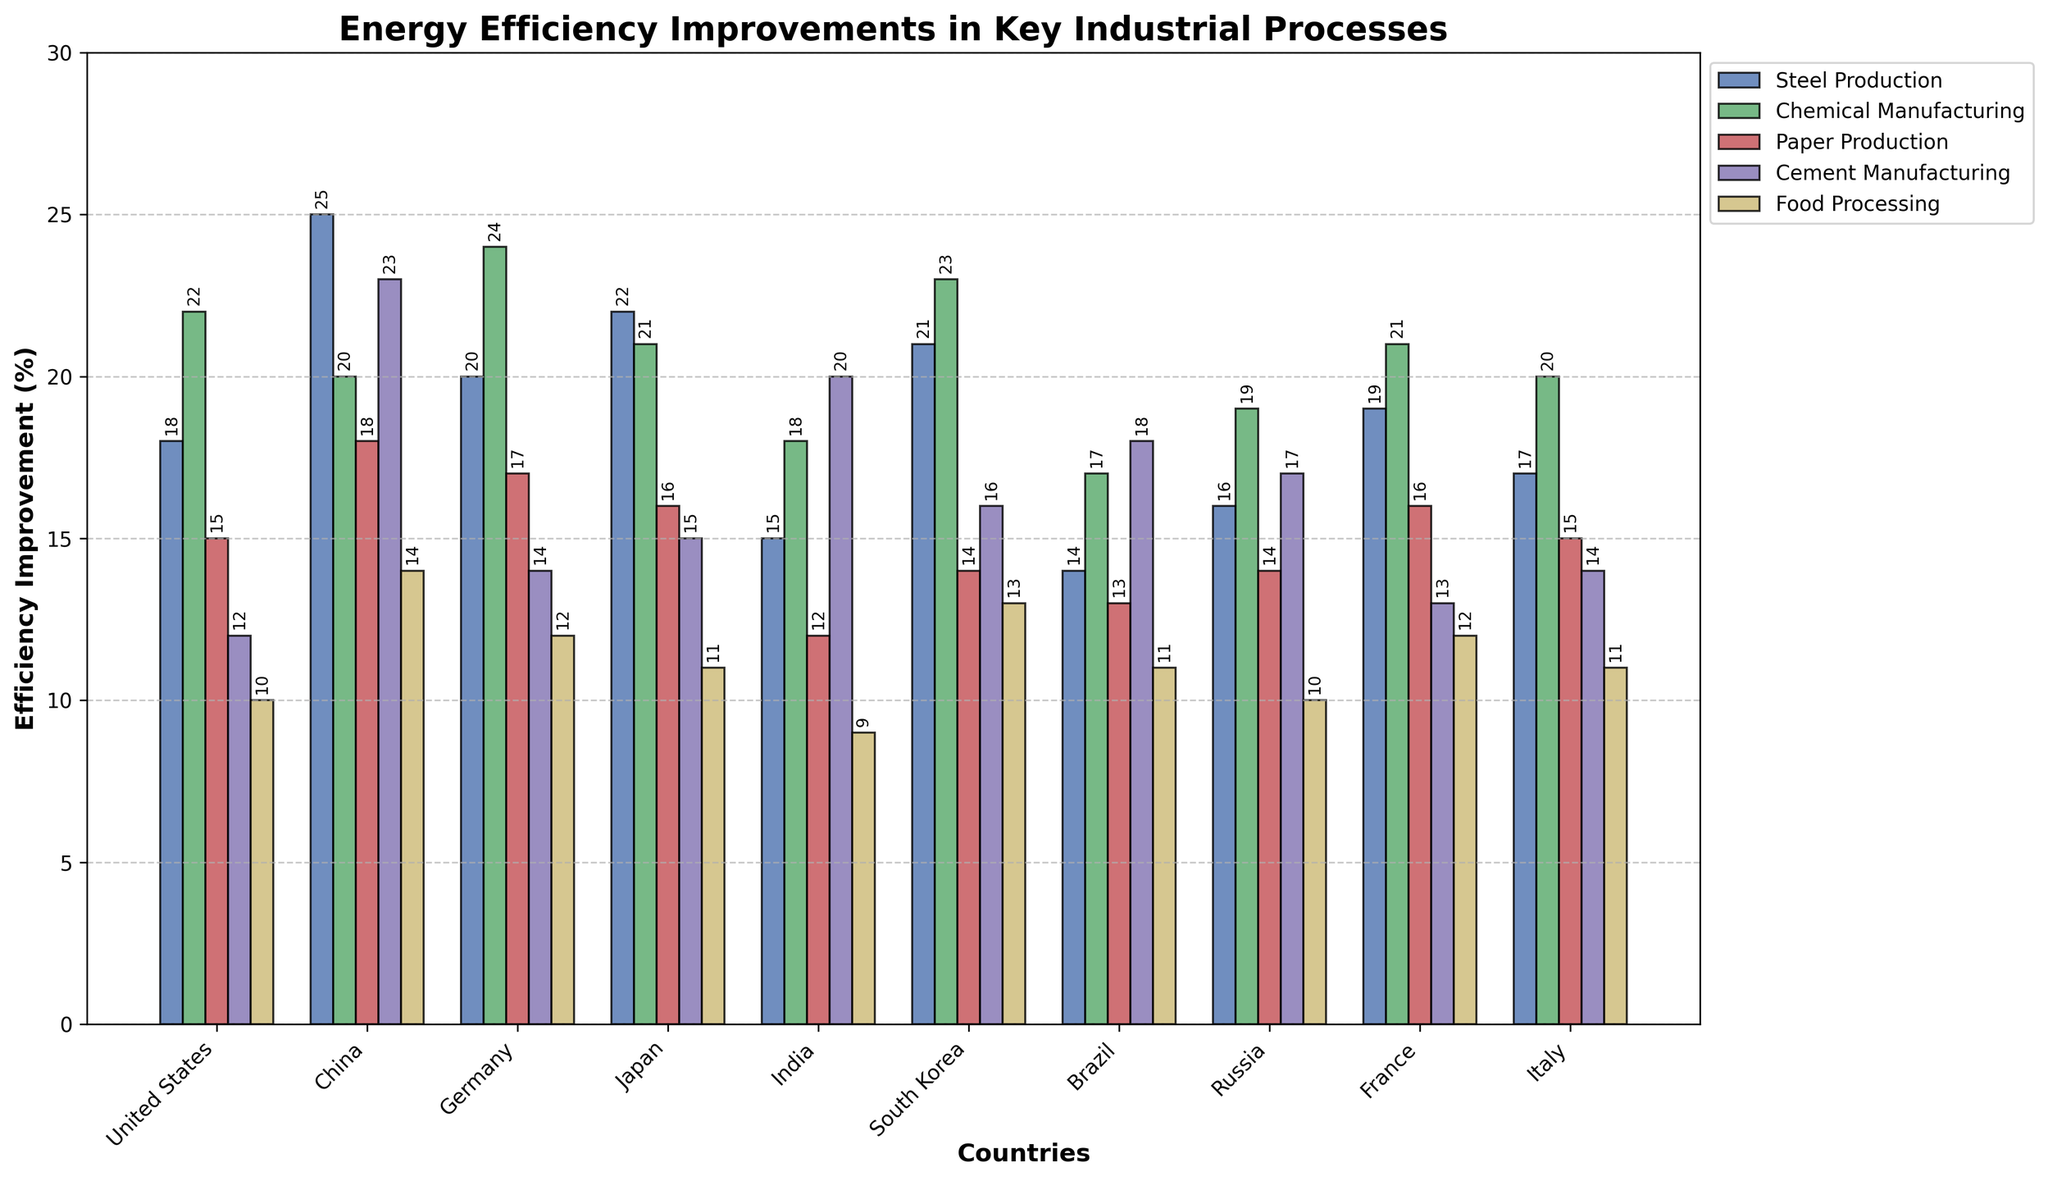What is the average energy efficiency improvement in Steel Production for all countries combined? First, sum the percentages of Steel Production efficiency improvements for each country: 18 (US) + 25 (China) + 20 (Germany) + 22 (Japan) + 15 (India) + 21 (South Korea) + 14 (Brazil) + 16 (Russia) + 19 (France) + 17 (Italy) = 187. Then, divide by the number of countries (10), so 187/10 = 18.7.
Answer: 18.7% Which country has the highest efficiency improvement in Chemical Manufacturing? By examining the heights of the Chemical Manufacturing bars, China, Germany, and South Korea are the only countries with improvements over 20%, where Germany has the highest at 24%.
Answer: Germany Which industrial process has the lowest efficiency improvement in India? By comparing the heights of the bars related to India, the shortest bar is Food Processing, with an efficiency improvement of 9%.
Answer: Food Processing Between the US and China, which country has a greater improvement in Paper Production? By comparing the heights of the Paper Production bars for the US and China, China's bar is higher with an improvement of 18% compared to the US's 15%.
Answer: China What is the difference in efficiency improvement in Cement Manufacturing between Germany and India? Germany has an improvement of 14%, and India has 20%. The difference is
Answer: 6% In which country do we see the greatest contrast in efficiency improvement between Cement Manufacturing and Food Processing? By comparing the differences between the Cement Manufacturing and Food Processing improvements in each country, China shows the greatest contrast: 23% (Cement Manufacturing) - 14% (Food Processing) = 9%.
Answer: China How does the Paper Production efficiency improvement in Brazil compare to that in South Korea? Brazil has an improvement of 13%, and South Korea has 14%. So, South Korea exceeds Brazil by 1%.
Answer: South Korea Which two countries show an equal improvement in Steel Production? By comparing the heights of the Steel Production bars, France and the US both have an efficiency improvement of 18%.
Answer: France and United States What is the combined efficiency improvement for Food Processing from all European countries listed (Germany, France, Italy)? Summing up the efficiency improvements for Food Processing in Germany (12%), France (12%), and Italy (11%) gives 12 + 12 + 11 = 35%.
Answer: 35% Which country has the most consistent range of improvements across all processes? By observing the bars for each country, the US has improvements relatively close together (10% to 22%), showing consistent performance.
Answer: United States 